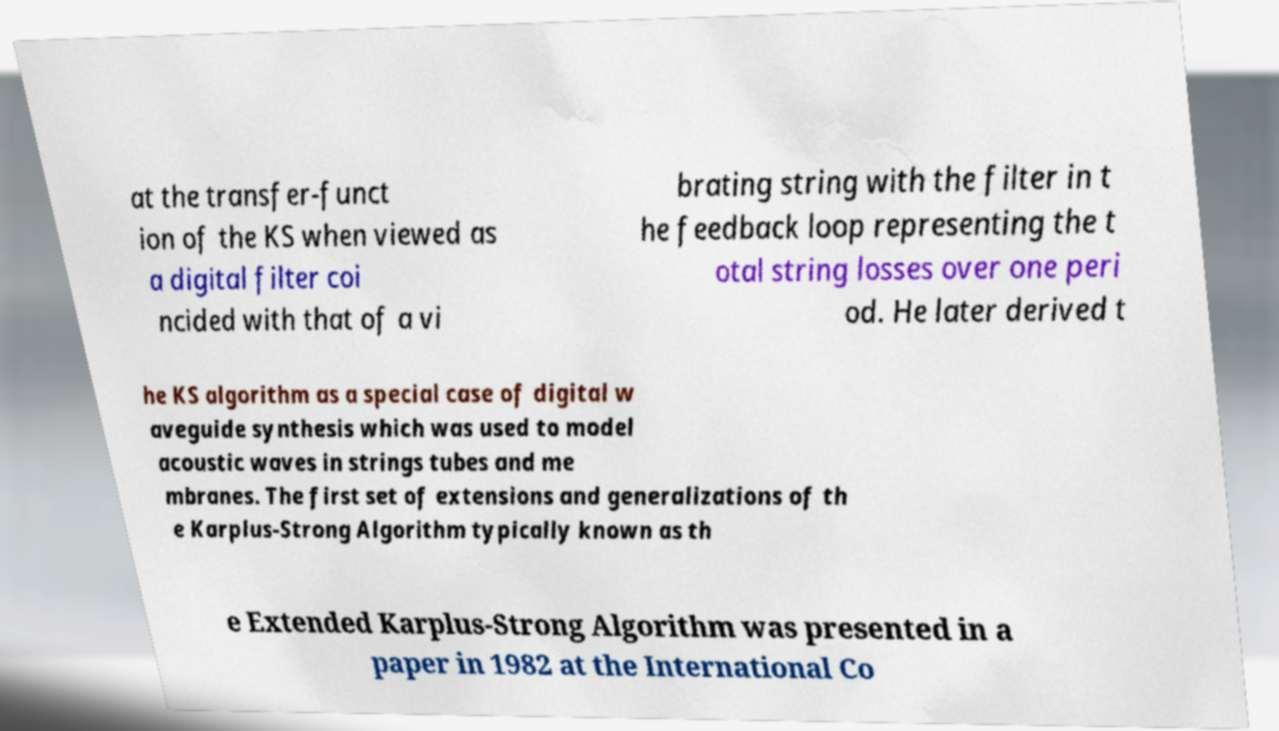Can you read and provide the text displayed in the image?This photo seems to have some interesting text. Can you extract and type it out for me? at the transfer-funct ion of the KS when viewed as a digital filter coi ncided with that of a vi brating string with the filter in t he feedback loop representing the t otal string losses over one peri od. He later derived t he KS algorithm as a special case of digital w aveguide synthesis which was used to model acoustic waves in strings tubes and me mbranes. The first set of extensions and generalizations of th e Karplus-Strong Algorithm typically known as th e Extended Karplus-Strong Algorithm was presented in a paper in 1982 at the International Co 